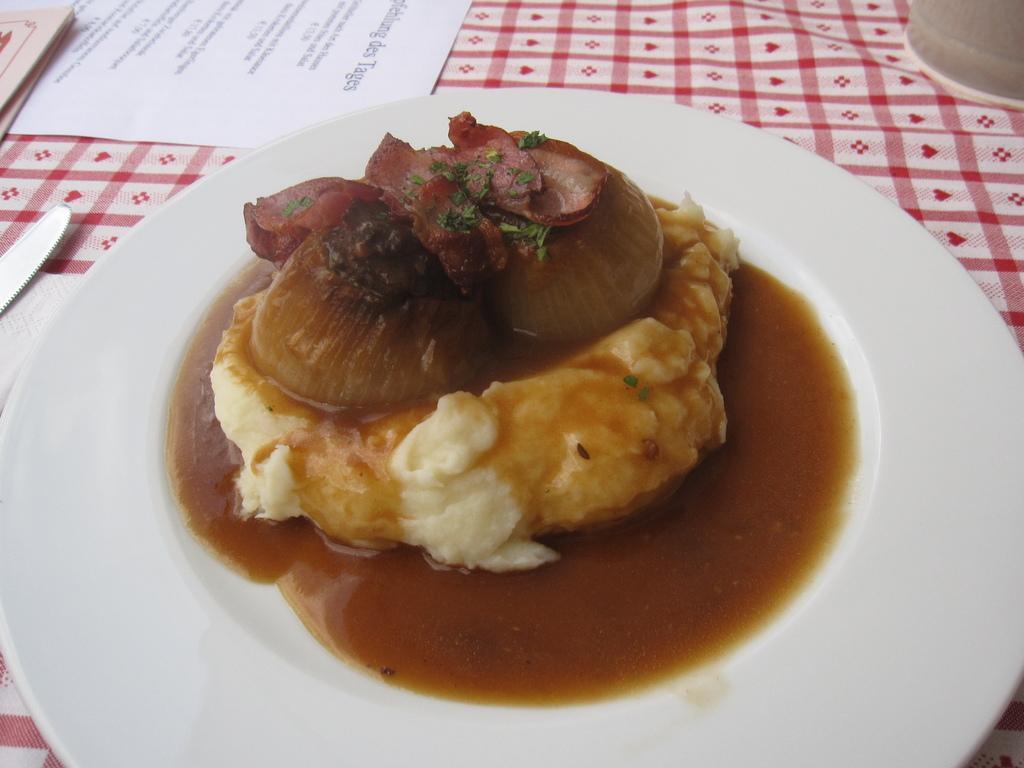Describe this image in one or two sentences. In this image I can see a white colour plate and in it I can see brown colour food. I can also see a knife, a white colour paper, pink colour cloth and on this paper I can see something is written. 